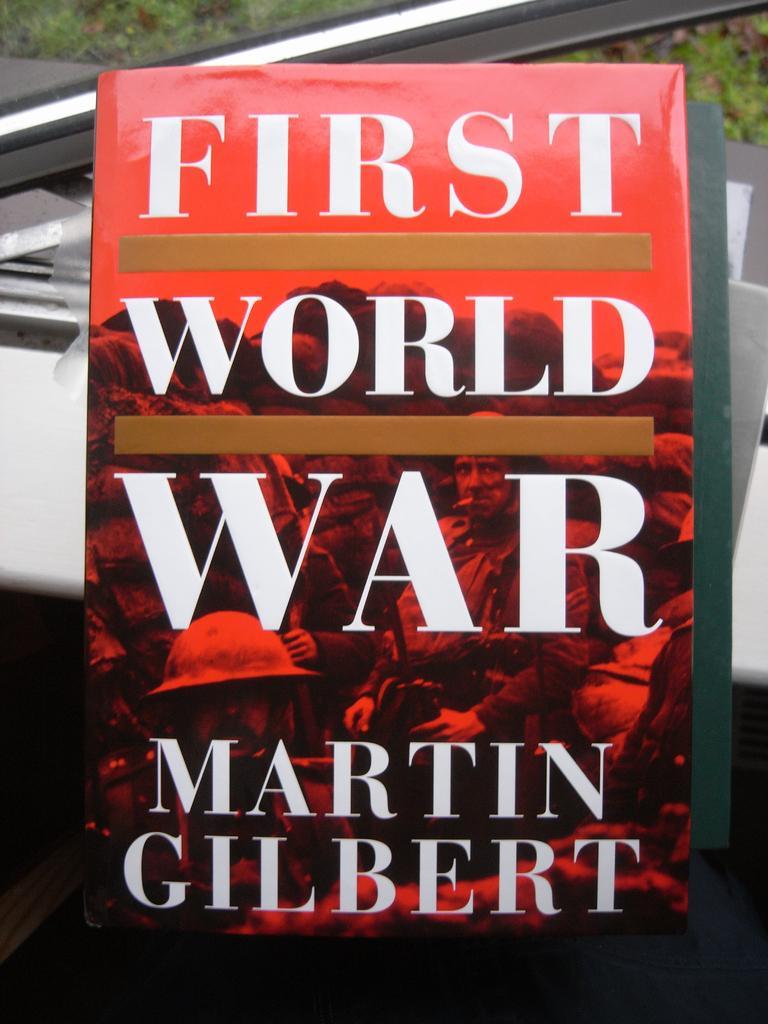How would you summarize this image in a sentence or two? In this picture we can see a book and in the background we can see the grass, some objects. 